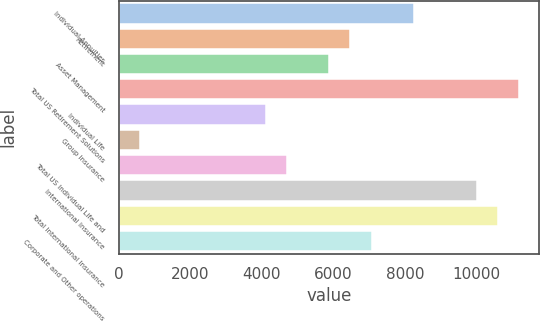<chart> <loc_0><loc_0><loc_500><loc_500><bar_chart><fcel>Individual Annuities<fcel>Retirement<fcel>Asset Management<fcel>Total US Retirement Solutions<fcel>Individual Life<fcel>Group Insurance<fcel>Total US Individual Life and<fcel>International Insurance<fcel>Total International Insurance<fcel>Corporate and Other operations<nl><fcel>8247.24<fcel>6480.78<fcel>5891.96<fcel>11191.3<fcel>4125.5<fcel>592.58<fcel>4714.32<fcel>10013.7<fcel>10602.5<fcel>7069.6<nl></chart> 